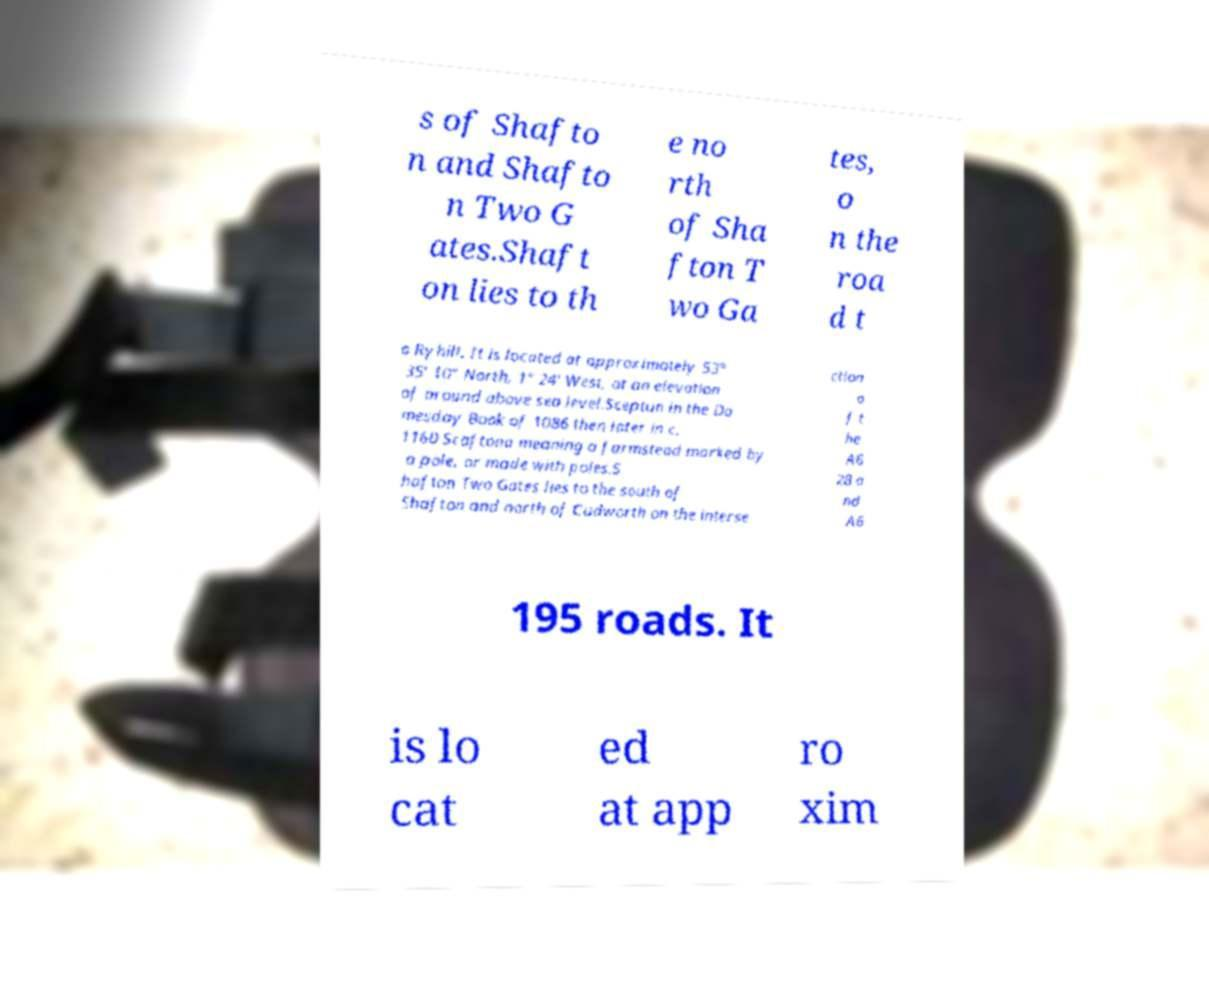What messages or text are displayed in this image? I need them in a readable, typed format. s of Shafto n and Shafto n Two G ates.Shaft on lies to th e no rth of Sha fton T wo Ga tes, o n the roa d t o Ryhill. It is located at approximately 53° 35' 10" North, 1° 24' West, at an elevation of around above sea level.Sceptun in the Do mesday Book of 1086 then later in c. 1160 Scaftona meaning a farmstead marked by a pole, or made with poles.S hafton Two Gates lies to the south of Shafton and north of Cudworth on the interse ction o f t he A6 28 a nd A6 195 roads. It is lo cat ed at app ro xim 